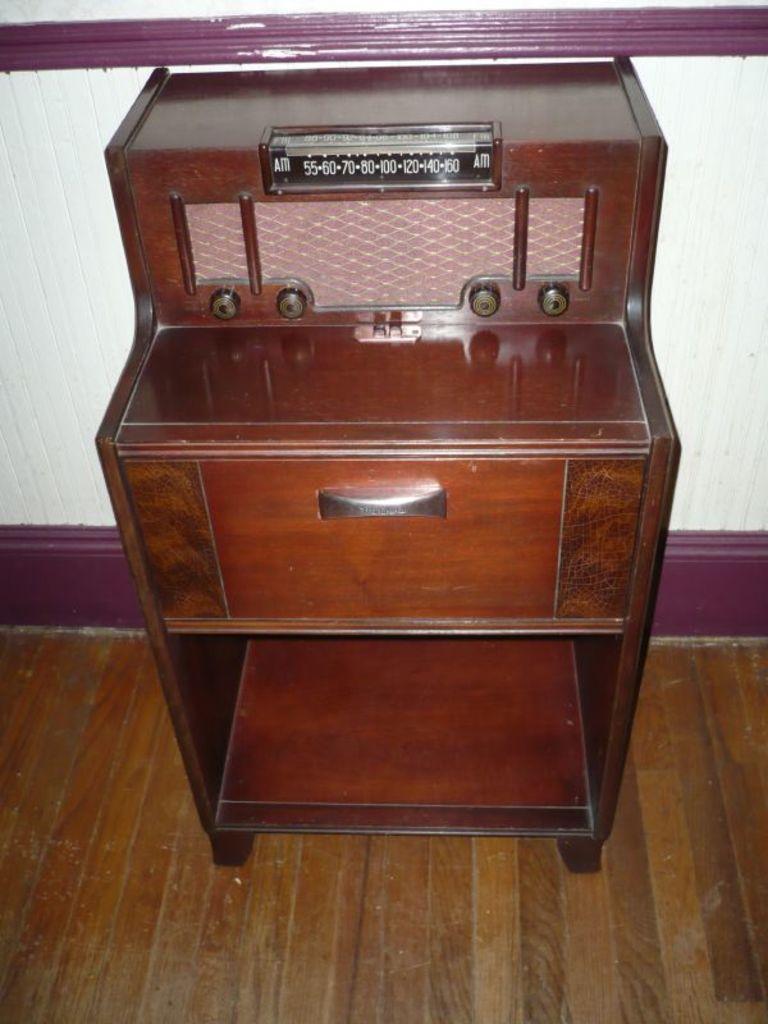Could you give a brief overview of what you see in this image? In the image we can see there is a wooden table kept on the floor. 